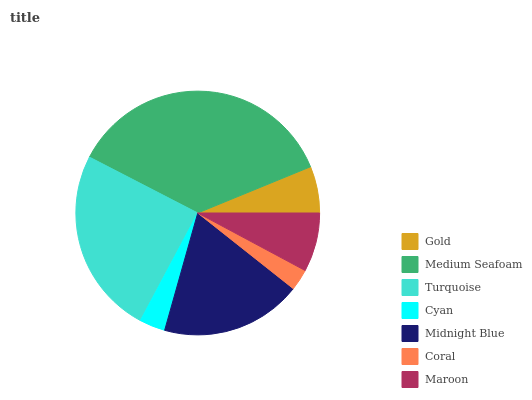Is Coral the minimum?
Answer yes or no. Yes. Is Medium Seafoam the maximum?
Answer yes or no. Yes. Is Turquoise the minimum?
Answer yes or no. No. Is Turquoise the maximum?
Answer yes or no. No. Is Medium Seafoam greater than Turquoise?
Answer yes or no. Yes. Is Turquoise less than Medium Seafoam?
Answer yes or no. Yes. Is Turquoise greater than Medium Seafoam?
Answer yes or no. No. Is Medium Seafoam less than Turquoise?
Answer yes or no. No. Is Maroon the high median?
Answer yes or no. Yes. Is Maroon the low median?
Answer yes or no. Yes. Is Cyan the high median?
Answer yes or no. No. Is Medium Seafoam the low median?
Answer yes or no. No. 